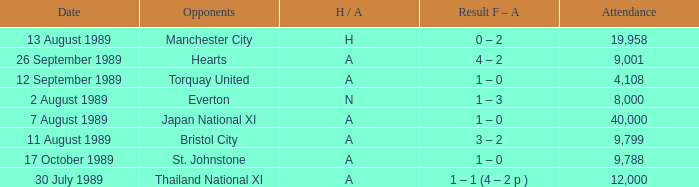When did Manchester United play against Bristol City with an H/A of A? 11 August 1989. 